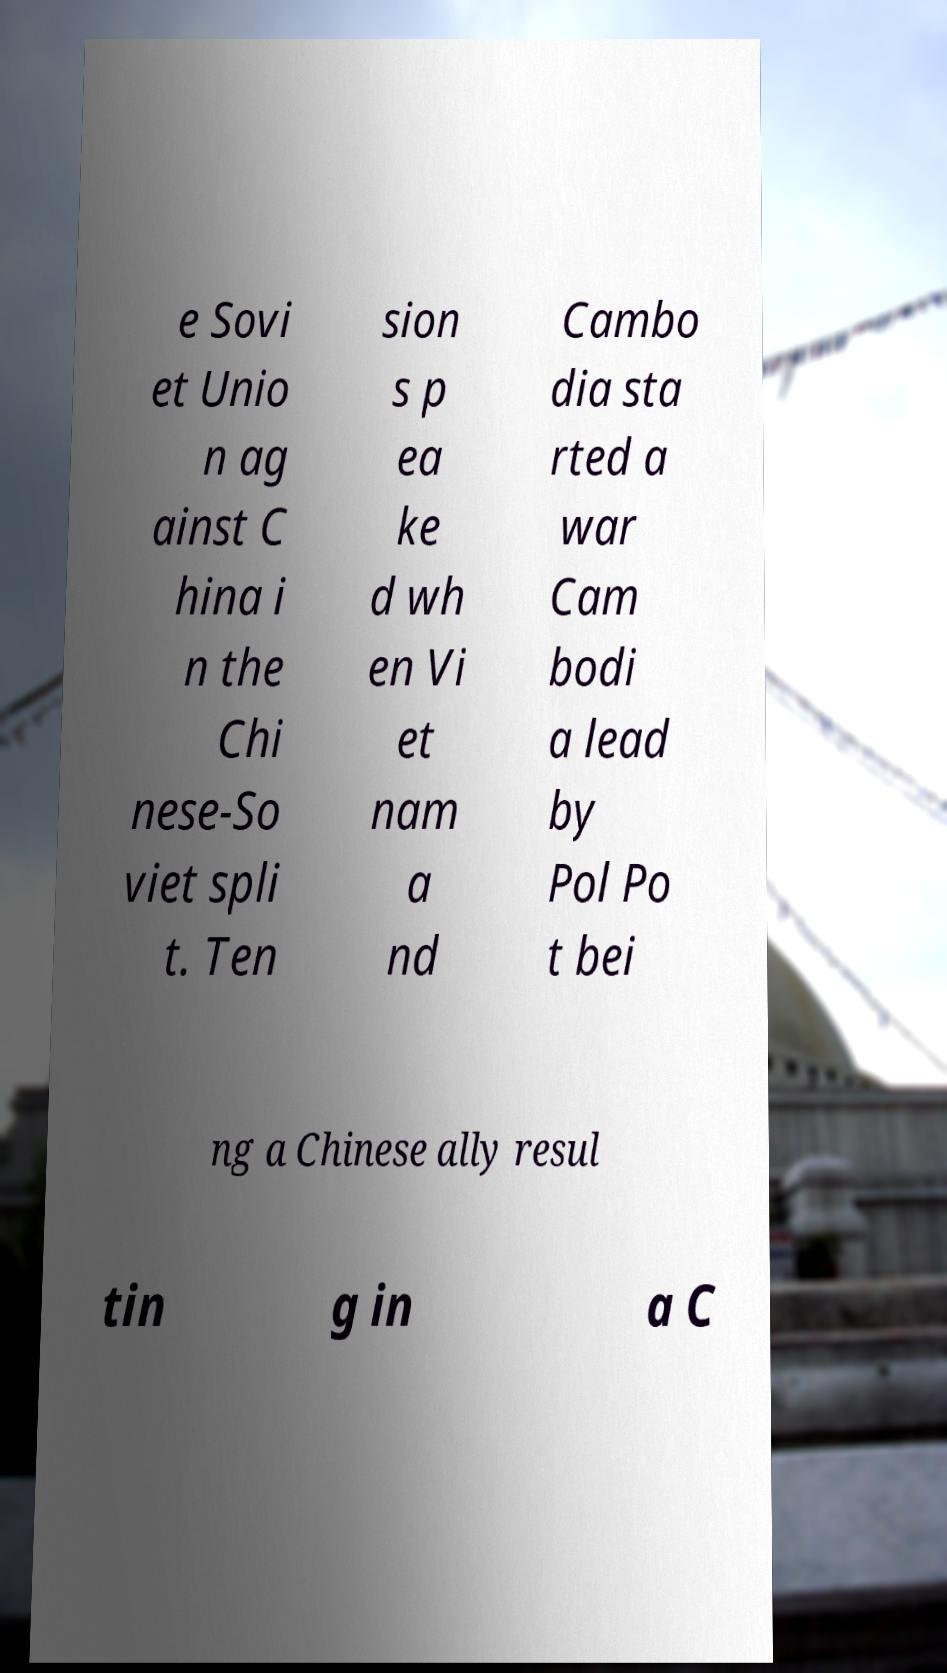Can you read and provide the text displayed in the image?This photo seems to have some interesting text. Can you extract and type it out for me? e Sovi et Unio n ag ainst C hina i n the Chi nese-So viet spli t. Ten sion s p ea ke d wh en Vi et nam a nd Cambo dia sta rted a war Cam bodi a lead by Pol Po t bei ng a Chinese ally resul tin g in a C 